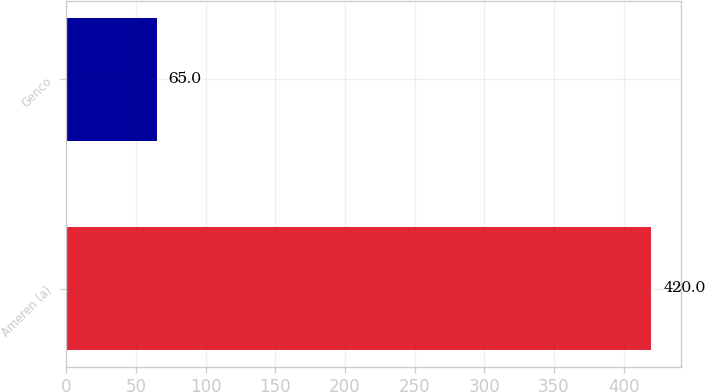Convert chart to OTSL. <chart><loc_0><loc_0><loc_500><loc_500><bar_chart><fcel>Ameren (a)<fcel>Genco<nl><fcel>420<fcel>65<nl></chart> 